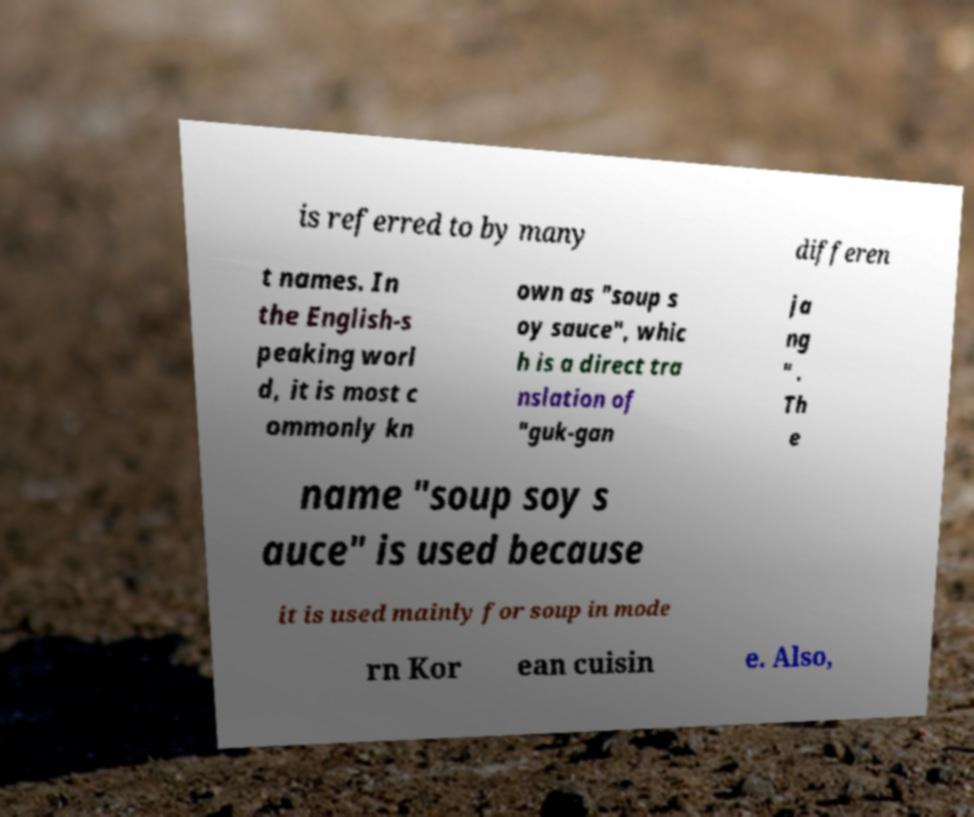Can you accurately transcribe the text from the provided image for me? is referred to by many differen t names. In the English-s peaking worl d, it is most c ommonly kn own as "soup s oy sauce", whic h is a direct tra nslation of "guk-gan ja ng " . Th e name "soup soy s auce" is used because it is used mainly for soup in mode rn Kor ean cuisin e. Also, 